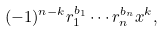<formula> <loc_0><loc_0><loc_500><loc_500>( - 1 ) ^ { n - k } r _ { 1 } ^ { b _ { 1 } } \cdots r _ { n } ^ { b _ { n } } x ^ { k } ,</formula> 